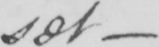Can you read and transcribe this handwriting? set  _ 